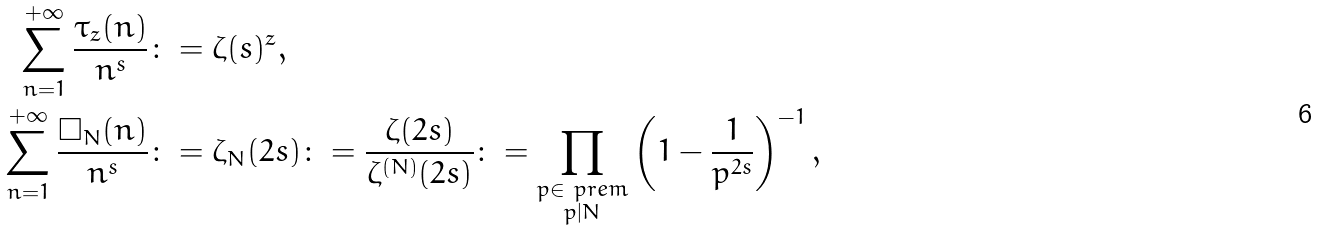<formula> <loc_0><loc_0><loc_500><loc_500>\sum _ { n = 1 } ^ { + \infty } \frac { \tau _ { z } ( n ) } { n ^ { s } } & \colon = \zeta ( s ) ^ { z } , \\ \sum _ { n = 1 } ^ { + \infty } \frac { \square _ { N } ( n ) } { n ^ { s } } & \colon = \zeta _ { N } ( 2 s ) \colon = \frac { \zeta ( 2 s ) } { \zeta ^ { ( N ) } ( 2 s ) } \colon = \prod _ { \substack { p \in \ p r e m \\ p | N } } \left ( 1 - \frac { 1 } { p ^ { 2 s } } \right ) ^ { - 1 } ,</formula> 